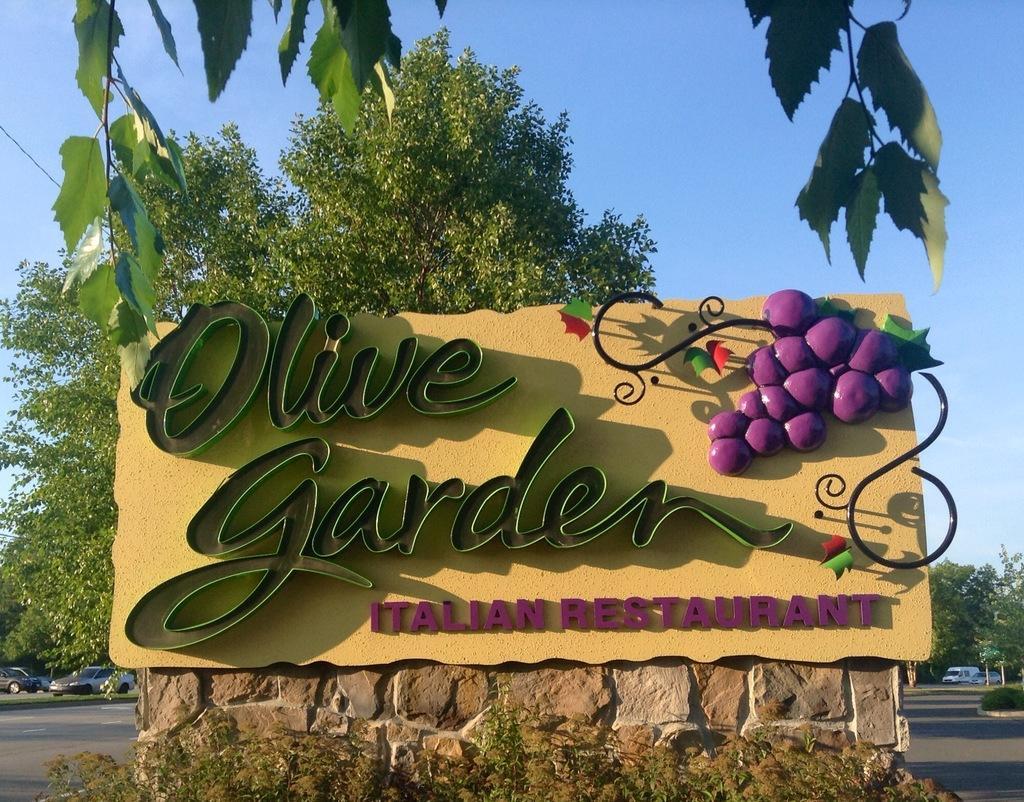Could you give a brief overview of what you see in this image? In this picture there is a board which has olive garden italian restaurant written on it and there are few trees and vehicles in the background. 